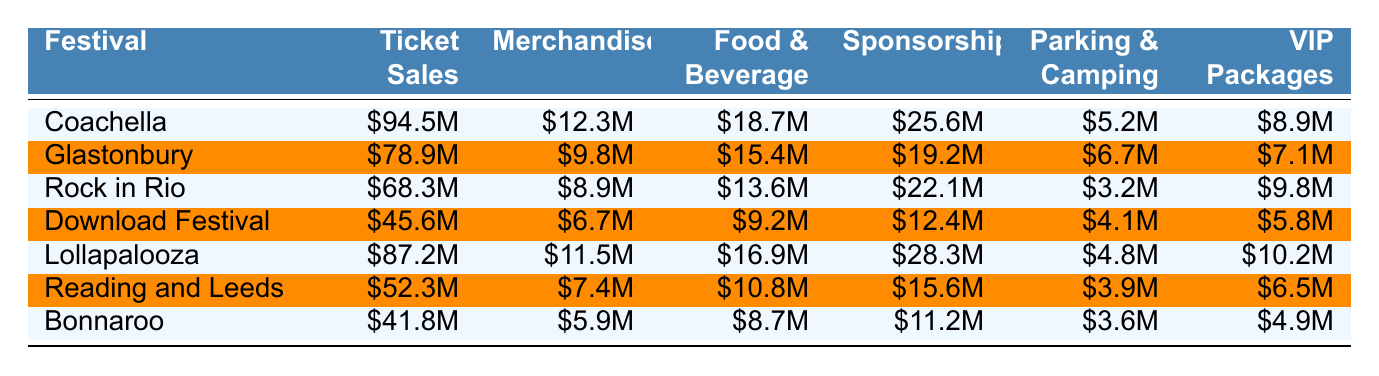What is the total ticket sales revenue for Coachella? The table shows Coachella's ticket sales revenue as $94.5 million.
Answer: $94.5 million Which festival had the highest merchandise income? By comparing the merchandise income, Lollapalooza had $11.5 million, which is the highest among all festivals listed.
Answer: Lollapalooza What was the total revenue from food and beverage at the Download Festival? The food and beverage revenue for the Download Festival is listed as $9.2 million.
Answer: $9.2 million Did Glastonbury have more VIP package income than Bonnaroo? Glastonbury's VIP package income is $7.1 million while Bonnaroo's is $4.9 million, so yes, Glastonbury had more.
Answer: Yes What is the total revenue from sponsorships across all festivals? The sums of sponsorship revenues: Coachella ($25.6M) + Glastonbury ($19.2M) + Rock in Rio ($22.1M) + Download Festival ($12.4M) + Lollapalooza ($28.3M) + Reading and Leeds ($15.6M) + Bonnaroo ($11.2M) gives $134.4 million.
Answer: $134.4 million What is the average food and beverage revenue for the festivals listed? The food and beverage revenues are: Coachella ($18.7M), Glastonbury ($15.4M), Rock in Rio ($13.6M), Download Festival ($9.2M), Lollapalooza ($16.9M), Reading and Leeds ($10.8M), Bonnaroo ($8.7M). Their total is $93.3 million, and dividing by 7 gives an average of approximately $13.33 million.
Answer: $13.33 million Which festival had the lowest total income from parking and camping? Bonnaroo has the lowest income from parking and camping at $3.6 million.
Answer: Bonnaroo What is the difference in ticket sales revenue between Glastonbury and Lollapalooza? Glastonbury's ticket sales are $78.9 million and Lollapalooza's are $87.2 million. The difference is $87.2 million - $78.9 million = $8.3 million.
Answer: $8.3 million Which festival generated less than $10 million in merchandise revenue? The festivals with merchandise revenue below $10 million are Glastonbury ($9.8M), Rock in Rio ($8.9M), Download Festival ($6.7M), and Bonnaroo ($5.9M).
Answer: 4 festivals If you combine the ticket sales and sponsorships for Rock in Rio, what is the total? Rock in Rio's ticket sales are $68.3 million and sponsorships are $22.1 million, so the total is $68.3 million + $22.1 million = $90.4 million.
Answer: $90.4 million 